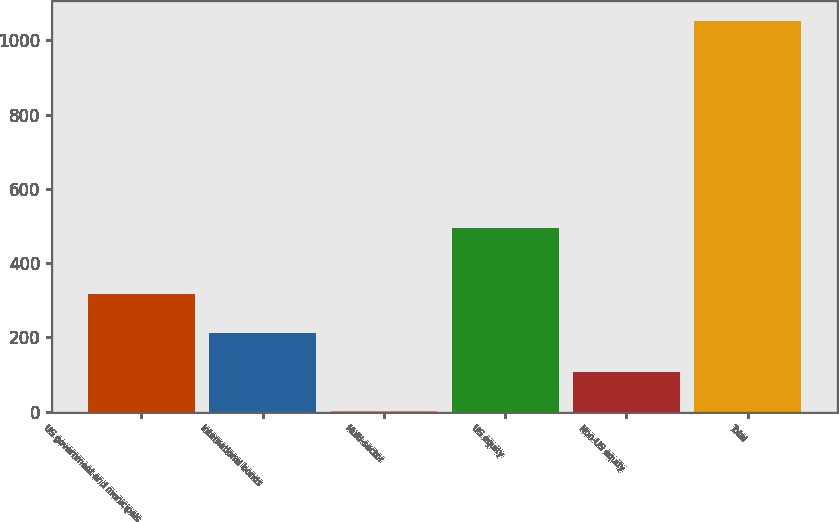<chart> <loc_0><loc_0><loc_500><loc_500><bar_chart><fcel>US government and municipals<fcel>International bonds<fcel>Multi-sector<fcel>US equity<fcel>Non-US equity<fcel>Total<nl><fcel>316.6<fcel>211.4<fcel>1<fcel>494<fcel>106.2<fcel>1053<nl></chart> 